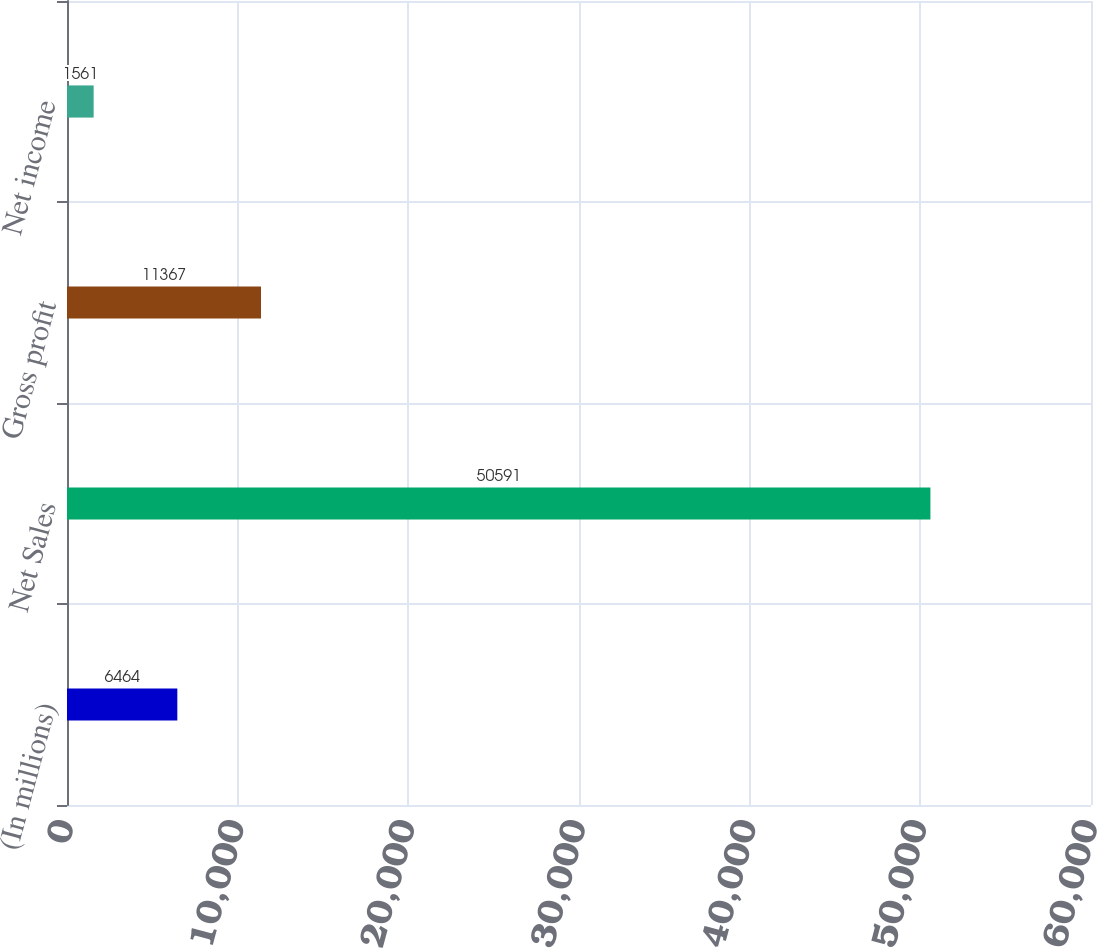Convert chart. <chart><loc_0><loc_0><loc_500><loc_500><bar_chart><fcel>(In millions)<fcel>Net Sales<fcel>Gross profit<fcel>Net income<nl><fcel>6464<fcel>50591<fcel>11367<fcel>1561<nl></chart> 